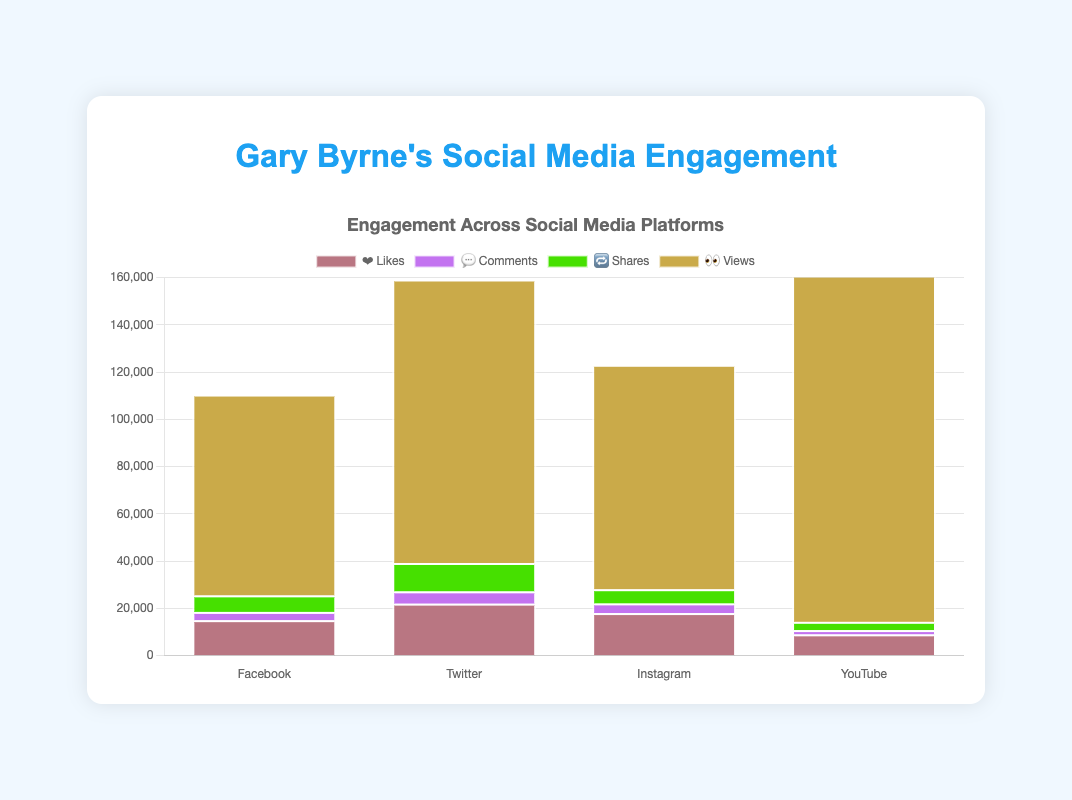What's the platform with the highest number of ❤️ Likes? Look at the "❤️ Likes" bar sections for each platform. The tallest bar section is for Twitter.
Answer: Twitter What's the total number of 💬 Comments across all platforms? Add the number of comments for each platform: 3500 (Facebook) + 5200 (Twitter) + 4100 (Instagram) + 1800 (YouTube) = 14600 comments.
Answer: 14600 Which platform has more 🔁 Shares, Facebook or Instagram? Compare the length of the "🔁 Shares" bar sections for Facebook and Instagram. Facebook has 7000 shares and Instagram has 6000 shares.
Answer: Facebook What's the difference in 👀 Views between Twitter and YouTube? Subtract the number of views for Twitter from those for YouTube: 150000 (YouTube) - 120000 (Twitter) = 30000 views.
Answer: 30000 What's the average number of ❤️ Likes per platform? Add the number of likes for all platforms and divide by four: (15000 + 22000 + 18000 + 9000) / 4 = 64000 / 4 = 16000 likes.
Answer: 16000 Which platform has the most engagement in terms of combined ❤️ Likes and 🔁 Shares? Calculate the combined number of likes and shares for each platform: Facebook (15000 + 7000), Twitter (22000 + 12000), Instagram (18000 + 6000), and YouTube (9000 + 3500). Twitter has 34000 combined likes and shares, which is the most.
Answer: Twitter Which metric sees the highest value across all platforms? Compare the highest values of each metric: Likes (22000), Comments (5200), Shares (12000), and Views (150000). The highest value is 150000 Views on YouTube.
Answer: Views on YouTube What's the total number of 🔁 Shares and 💬 Comments on Instagram? Add the shares and comments on Instagram: 6000 (Shares) + 4100 (Comments) = 10100.
Answer: 10100 How many more 👀 Views are there on YouTube compared to Instagram? Subtract the number of views on Instagram from those on YouTube: 150000 (YouTube) - 95000 (Instagram) = 55000 views.
Answer: 55000 